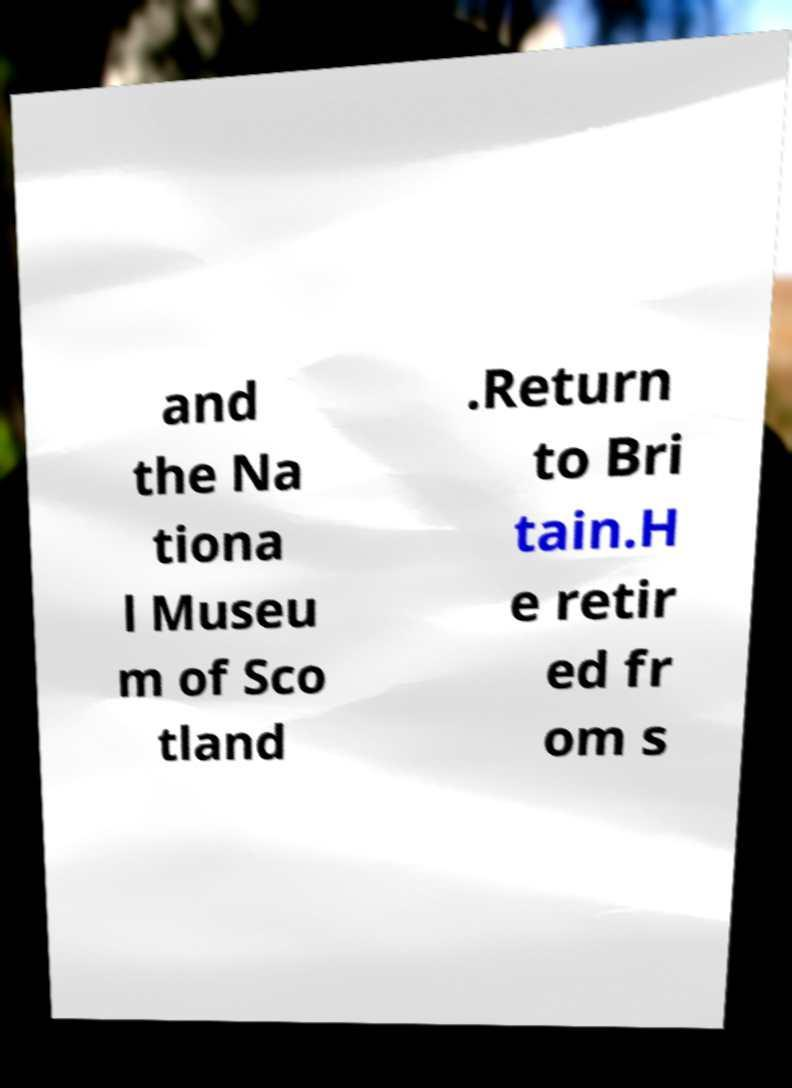Can you read and provide the text displayed in the image?This photo seems to have some interesting text. Can you extract and type it out for me? and the Na tiona l Museu m of Sco tland .Return to Bri tain.H e retir ed fr om s 